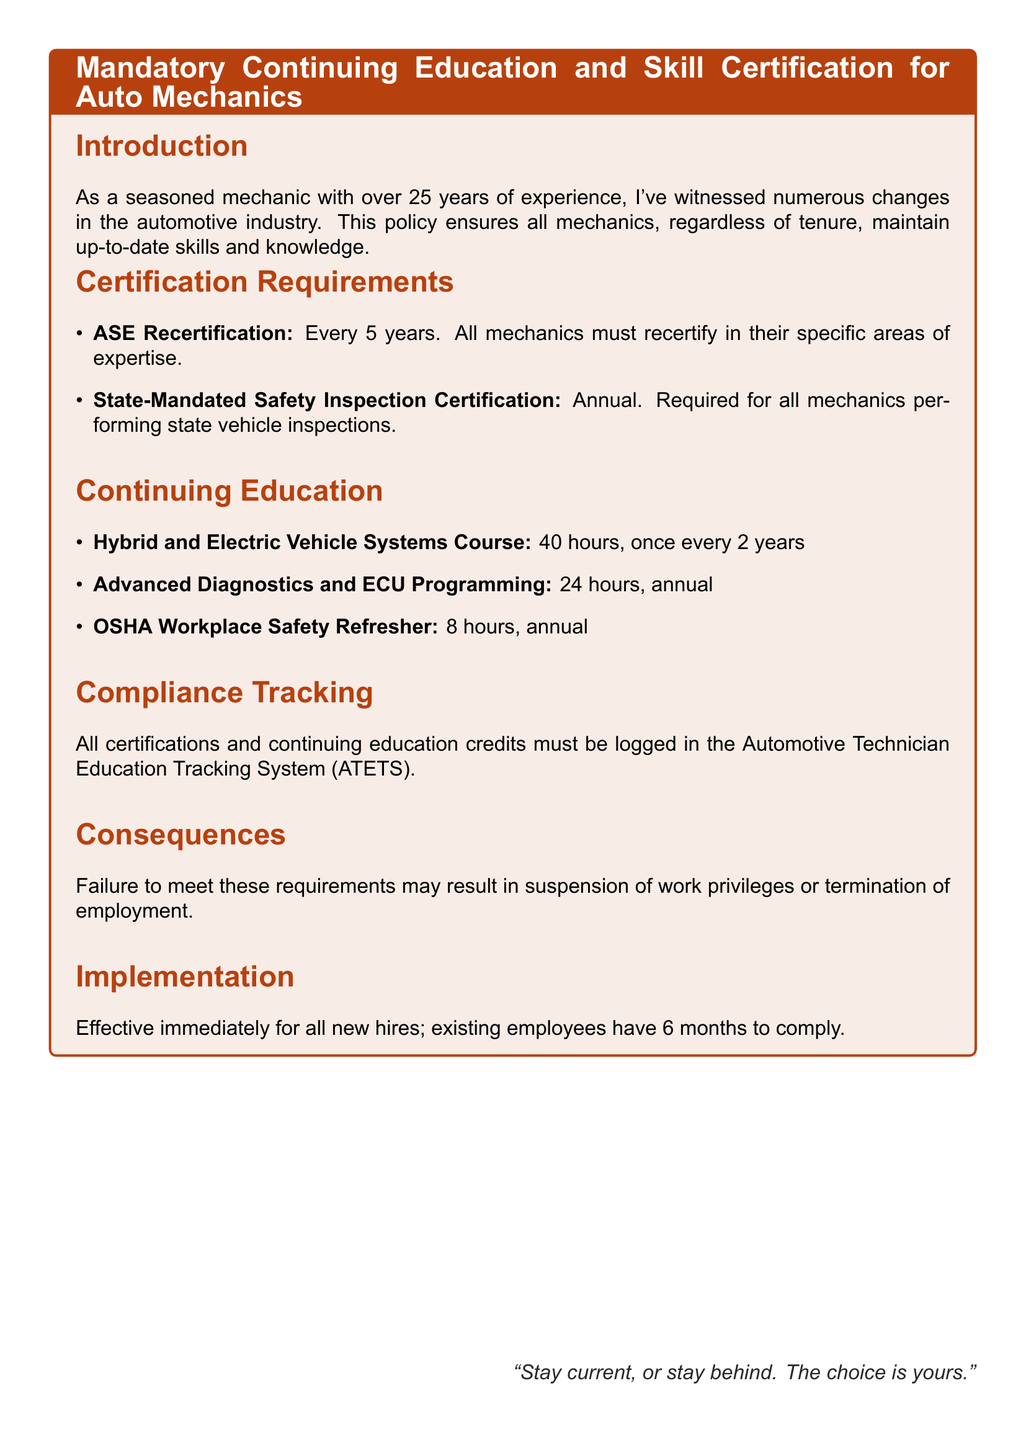What is the ASE recertification period? The ASE recertification period is specified in the certification requirements section of the document, stating it must occur every 5 years.
Answer: 5 years How many hours of continuing education are required for the Hybrid and Electric Vehicle Systems Course? The document lists the hours required for each continuing education course, indicating that the Hybrid and Electric Vehicle Systems Course requires 40 hours.
Answer: 40 hours What is the annual requirement for the OSHA Workplace Safety Refresher? This requirement is detailed in the continuing education section, specifying the OSHA Workplace Safety Refresher requires 8 hours annually.
Answer: 8 hours What happens if a mechanic fails to meet the requirements? The document mentions consequences for failing to meet the requirements, specifically indicating that such failure could lead to suspension of work privileges or termination of employment.
Answer: Suspension or termination How often must mechanics recertify for state-mandated safety inspections? The certification requirements section outlines how often various certifications need to be renewed, indicating that state-mandated safety inspection certification must be renewed annually.
Answer: Annual When do existing employees need to comply with the new requirements? The implementation section specifies the time frame for compliance for existing employees, indicating they have 6 months to comply.
Answer: 6 months What system must certifications and credits be logged in? The compliance tracking section of the document identifies the Automotive Technician Education Tracking System as the required log for certifications and continuing education credits.
Answer: ATETS How many hours of continuing education are required for Advanced Diagnostics and ECU Programming? The document explicitly states the number of hours required for this continuing education course, which is 24 hours annually.
Answer: 24 hours 